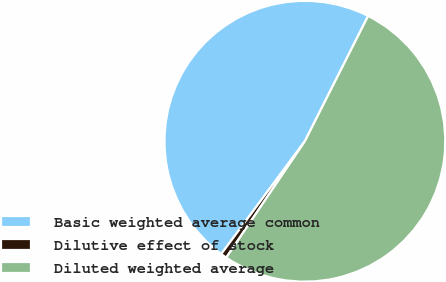Convert chart. <chart><loc_0><loc_0><loc_500><loc_500><pie_chart><fcel>Basic weighted average common<fcel>Dilutive effect of stock<fcel>Diluted weighted average<nl><fcel>47.29%<fcel>0.7%<fcel>52.02%<nl></chart> 